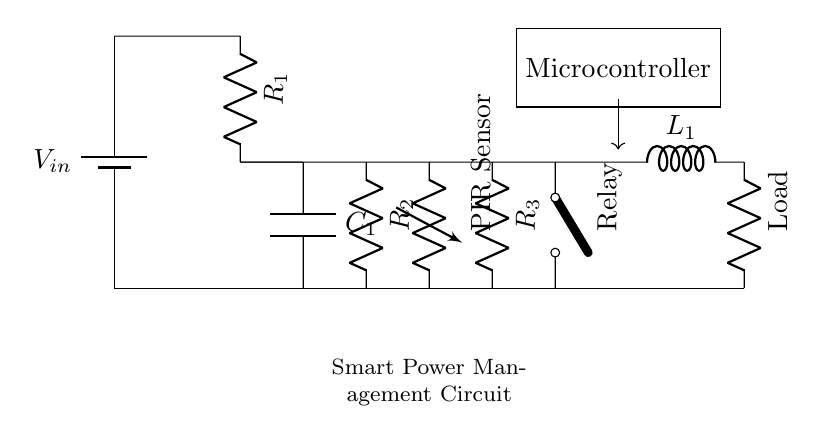What is the input voltage of the circuit? The input voltage is denoted by V_in, which is typically labeled at the battery symbol. This indicates where the voltage is sourced in the circuit.
Answer: V_in What component controls the relay in this circuit? The component that controls the relay is the microcontroller, as it is represented in a rectangle labeled "Microcontroller." It is connected to the relay via a line, indicating control signal flow.
Answer: Microcontroller What is the purpose of the PIR sensor in this circuit? The PIR sensor detects motion, which can signal the microcontroller to activate or deactivate the relay based on the presence of people, making it essential for the automatic standby function.
Answer: Motion detection How many resistors are present in the circuit? The circuit diagram includes three resistors, labeled R1, R2, and R3, which are indicated by the R symbols scattered throughout the design.
Answer: Three Explain the role of the capacitor in the circuit. The role of the capacitor, labeled C1, is to store energy and smooth out the voltage variations in the circuit, especially during the switching of the relay, which helps maintain stable operation.
Answer: Energy storage What happens to the load when the PIR sensor detects no motion? When the PIR sensor detects no motion, it likely sends a signal to the microcontroller to deactivate the relay, resulting in the load being turned off and entering standby mode, conserving energy.
Answer: Load off Which component provides the power to the circuit? The power to the circuit is provided by the battery, indicated at the start as V_in, which supplies the necessary voltage for all components to operate.
Answer: Battery 